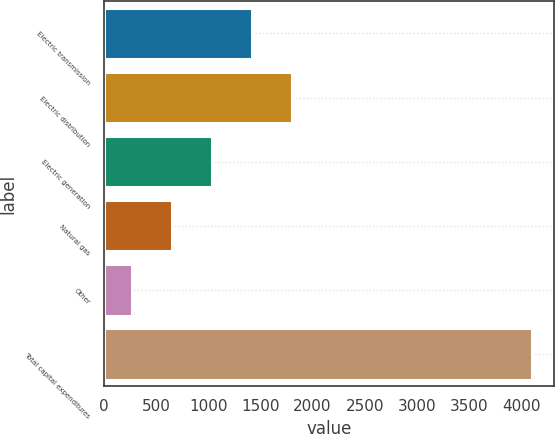Convert chart. <chart><loc_0><loc_0><loc_500><loc_500><bar_chart><fcel>Electric transmission<fcel>Electric distribution<fcel>Electric generation<fcel>Natural gas<fcel>Other<fcel>Total capital expenditures<nl><fcel>1417<fcel>1801<fcel>1033<fcel>649<fcel>265<fcel>4105<nl></chart> 